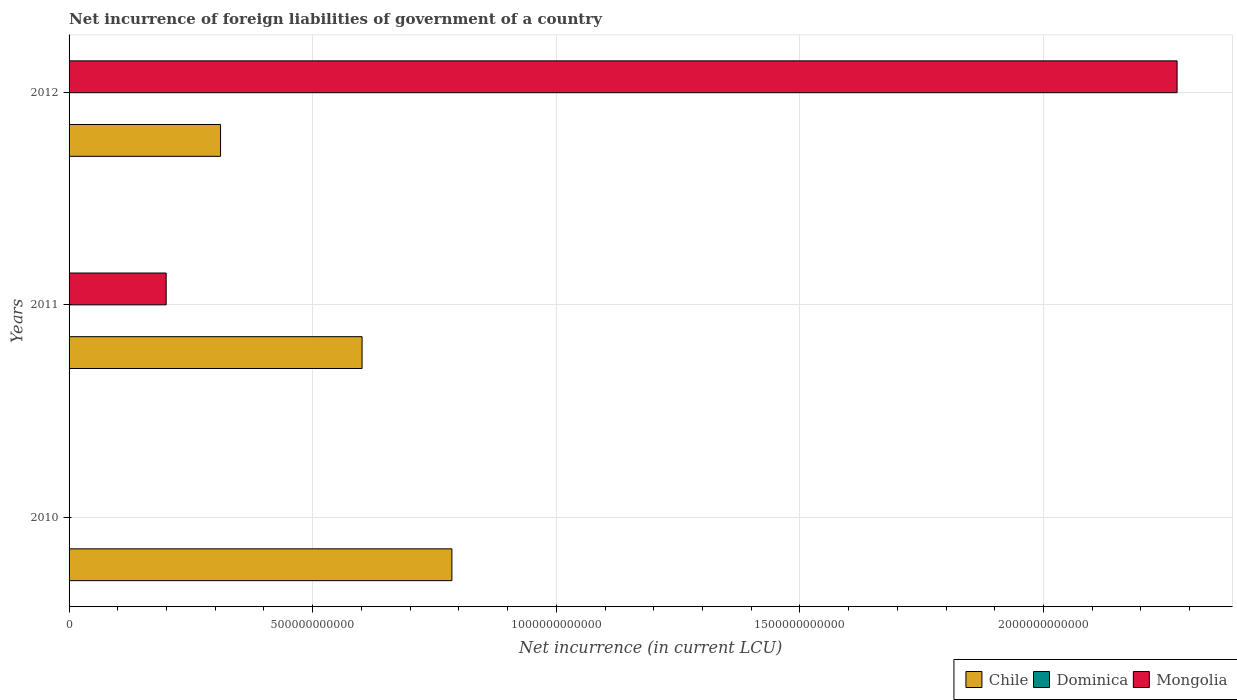How many different coloured bars are there?
Offer a terse response. 3. How many groups of bars are there?
Your response must be concise. 3. Are the number of bars on each tick of the Y-axis equal?
Your answer should be very brief. No. How many bars are there on the 2nd tick from the top?
Give a very brief answer. 3. How many bars are there on the 1st tick from the bottom?
Your response must be concise. 2. In how many cases, is the number of bars for a given year not equal to the number of legend labels?
Provide a succinct answer. 1. What is the net incurrence of foreign liabilities in Dominica in 2012?
Your answer should be very brief. 7.28e+07. Across all years, what is the maximum net incurrence of foreign liabilities in Mongolia?
Provide a succinct answer. 2.27e+12. Across all years, what is the minimum net incurrence of foreign liabilities in Dominica?
Your response must be concise. 2.72e+07. In which year was the net incurrence of foreign liabilities in Dominica maximum?
Your response must be concise. 2012. What is the total net incurrence of foreign liabilities in Dominica in the graph?
Your answer should be very brief. 1.48e+08. What is the difference between the net incurrence of foreign liabilities in Chile in 2010 and that in 2011?
Your response must be concise. 1.84e+11. What is the difference between the net incurrence of foreign liabilities in Mongolia in 2011 and the net incurrence of foreign liabilities in Chile in 2012?
Provide a short and direct response. -1.12e+11. What is the average net incurrence of foreign liabilities in Mongolia per year?
Ensure brevity in your answer.  8.24e+11. In the year 2011, what is the difference between the net incurrence of foreign liabilities in Dominica and net incurrence of foreign liabilities in Chile?
Your answer should be very brief. -6.01e+11. In how many years, is the net incurrence of foreign liabilities in Chile greater than 1500000000000 LCU?
Offer a very short reply. 0. What is the ratio of the net incurrence of foreign liabilities in Dominica in 2010 to that in 2012?
Your response must be concise. 0.66. Is the difference between the net incurrence of foreign liabilities in Dominica in 2010 and 2012 greater than the difference between the net incurrence of foreign liabilities in Chile in 2010 and 2012?
Provide a succinct answer. No. What is the difference between the highest and the second highest net incurrence of foreign liabilities in Dominica?
Your answer should be very brief. 2.48e+07. What is the difference between the highest and the lowest net incurrence of foreign liabilities in Chile?
Provide a short and direct response. 4.75e+11. In how many years, is the net incurrence of foreign liabilities in Chile greater than the average net incurrence of foreign liabilities in Chile taken over all years?
Offer a terse response. 2. Is it the case that in every year, the sum of the net incurrence of foreign liabilities in Dominica and net incurrence of foreign liabilities in Chile is greater than the net incurrence of foreign liabilities in Mongolia?
Provide a succinct answer. No. Are all the bars in the graph horizontal?
Offer a terse response. Yes. What is the difference between two consecutive major ticks on the X-axis?
Provide a short and direct response. 5.00e+11. Are the values on the major ticks of X-axis written in scientific E-notation?
Your answer should be very brief. No. Does the graph contain any zero values?
Offer a terse response. Yes. How many legend labels are there?
Offer a very short reply. 3. How are the legend labels stacked?
Your answer should be compact. Horizontal. What is the title of the graph?
Make the answer very short. Net incurrence of foreign liabilities of government of a country. Does "Guam" appear as one of the legend labels in the graph?
Your answer should be very brief. No. What is the label or title of the X-axis?
Offer a very short reply. Net incurrence (in current LCU). What is the Net incurrence (in current LCU) in Chile in 2010?
Offer a terse response. 7.86e+11. What is the Net incurrence (in current LCU) in Dominica in 2010?
Offer a very short reply. 4.80e+07. What is the Net incurrence (in current LCU) in Chile in 2011?
Make the answer very short. 6.01e+11. What is the Net incurrence (in current LCU) in Dominica in 2011?
Ensure brevity in your answer.  2.72e+07. What is the Net incurrence (in current LCU) of Mongolia in 2011?
Offer a very short reply. 1.99e+11. What is the Net incurrence (in current LCU) of Chile in 2012?
Give a very brief answer. 3.11e+11. What is the Net incurrence (in current LCU) of Dominica in 2012?
Make the answer very short. 7.28e+07. What is the Net incurrence (in current LCU) in Mongolia in 2012?
Your answer should be very brief. 2.27e+12. Across all years, what is the maximum Net incurrence (in current LCU) of Chile?
Offer a terse response. 7.86e+11. Across all years, what is the maximum Net incurrence (in current LCU) of Dominica?
Make the answer very short. 7.28e+07. Across all years, what is the maximum Net incurrence (in current LCU) in Mongolia?
Provide a short and direct response. 2.27e+12. Across all years, what is the minimum Net incurrence (in current LCU) in Chile?
Give a very brief answer. 3.11e+11. Across all years, what is the minimum Net incurrence (in current LCU) of Dominica?
Offer a very short reply. 2.72e+07. Across all years, what is the minimum Net incurrence (in current LCU) in Mongolia?
Provide a succinct answer. 0. What is the total Net incurrence (in current LCU) in Chile in the graph?
Offer a terse response. 1.70e+12. What is the total Net incurrence (in current LCU) of Dominica in the graph?
Your response must be concise. 1.48e+08. What is the total Net incurrence (in current LCU) of Mongolia in the graph?
Ensure brevity in your answer.  2.47e+12. What is the difference between the Net incurrence (in current LCU) in Chile in 2010 and that in 2011?
Ensure brevity in your answer.  1.84e+11. What is the difference between the Net incurrence (in current LCU) in Dominica in 2010 and that in 2011?
Give a very brief answer. 2.08e+07. What is the difference between the Net incurrence (in current LCU) in Chile in 2010 and that in 2012?
Provide a succinct answer. 4.75e+11. What is the difference between the Net incurrence (in current LCU) in Dominica in 2010 and that in 2012?
Your answer should be compact. -2.48e+07. What is the difference between the Net incurrence (in current LCU) of Chile in 2011 and that in 2012?
Offer a terse response. 2.90e+11. What is the difference between the Net incurrence (in current LCU) of Dominica in 2011 and that in 2012?
Your answer should be very brief. -4.56e+07. What is the difference between the Net incurrence (in current LCU) of Mongolia in 2011 and that in 2012?
Your response must be concise. -2.07e+12. What is the difference between the Net incurrence (in current LCU) of Chile in 2010 and the Net incurrence (in current LCU) of Dominica in 2011?
Ensure brevity in your answer.  7.86e+11. What is the difference between the Net incurrence (in current LCU) in Chile in 2010 and the Net incurrence (in current LCU) in Mongolia in 2011?
Ensure brevity in your answer.  5.86e+11. What is the difference between the Net incurrence (in current LCU) in Dominica in 2010 and the Net incurrence (in current LCU) in Mongolia in 2011?
Your response must be concise. -1.99e+11. What is the difference between the Net incurrence (in current LCU) of Chile in 2010 and the Net incurrence (in current LCU) of Dominica in 2012?
Offer a terse response. 7.86e+11. What is the difference between the Net incurrence (in current LCU) in Chile in 2010 and the Net incurrence (in current LCU) in Mongolia in 2012?
Offer a very short reply. -1.49e+12. What is the difference between the Net incurrence (in current LCU) in Dominica in 2010 and the Net incurrence (in current LCU) in Mongolia in 2012?
Keep it short and to the point. -2.27e+12. What is the difference between the Net incurrence (in current LCU) in Chile in 2011 and the Net incurrence (in current LCU) in Dominica in 2012?
Provide a succinct answer. 6.01e+11. What is the difference between the Net incurrence (in current LCU) in Chile in 2011 and the Net incurrence (in current LCU) in Mongolia in 2012?
Ensure brevity in your answer.  -1.67e+12. What is the difference between the Net incurrence (in current LCU) in Dominica in 2011 and the Net incurrence (in current LCU) in Mongolia in 2012?
Make the answer very short. -2.27e+12. What is the average Net incurrence (in current LCU) in Chile per year?
Keep it short and to the point. 5.66e+11. What is the average Net incurrence (in current LCU) in Dominica per year?
Offer a very short reply. 4.93e+07. What is the average Net incurrence (in current LCU) of Mongolia per year?
Your response must be concise. 8.24e+11. In the year 2010, what is the difference between the Net incurrence (in current LCU) in Chile and Net incurrence (in current LCU) in Dominica?
Your response must be concise. 7.86e+11. In the year 2011, what is the difference between the Net incurrence (in current LCU) of Chile and Net incurrence (in current LCU) of Dominica?
Make the answer very short. 6.01e+11. In the year 2011, what is the difference between the Net incurrence (in current LCU) of Chile and Net incurrence (in current LCU) of Mongolia?
Offer a very short reply. 4.02e+11. In the year 2011, what is the difference between the Net incurrence (in current LCU) in Dominica and Net incurrence (in current LCU) in Mongolia?
Offer a very short reply. -1.99e+11. In the year 2012, what is the difference between the Net incurrence (in current LCU) of Chile and Net incurrence (in current LCU) of Dominica?
Your response must be concise. 3.11e+11. In the year 2012, what is the difference between the Net incurrence (in current LCU) in Chile and Net incurrence (in current LCU) in Mongolia?
Make the answer very short. -1.96e+12. In the year 2012, what is the difference between the Net incurrence (in current LCU) of Dominica and Net incurrence (in current LCU) of Mongolia?
Your response must be concise. -2.27e+12. What is the ratio of the Net incurrence (in current LCU) of Chile in 2010 to that in 2011?
Keep it short and to the point. 1.31. What is the ratio of the Net incurrence (in current LCU) of Dominica in 2010 to that in 2011?
Make the answer very short. 1.76. What is the ratio of the Net incurrence (in current LCU) of Chile in 2010 to that in 2012?
Your answer should be compact. 2.53. What is the ratio of the Net incurrence (in current LCU) in Dominica in 2010 to that in 2012?
Offer a very short reply. 0.66. What is the ratio of the Net incurrence (in current LCU) of Chile in 2011 to that in 2012?
Make the answer very short. 1.93. What is the ratio of the Net incurrence (in current LCU) in Dominica in 2011 to that in 2012?
Your answer should be compact. 0.37. What is the ratio of the Net incurrence (in current LCU) of Mongolia in 2011 to that in 2012?
Keep it short and to the point. 0.09. What is the difference between the highest and the second highest Net incurrence (in current LCU) of Chile?
Offer a very short reply. 1.84e+11. What is the difference between the highest and the second highest Net incurrence (in current LCU) in Dominica?
Your answer should be very brief. 2.48e+07. What is the difference between the highest and the lowest Net incurrence (in current LCU) in Chile?
Offer a terse response. 4.75e+11. What is the difference between the highest and the lowest Net incurrence (in current LCU) in Dominica?
Give a very brief answer. 4.56e+07. What is the difference between the highest and the lowest Net incurrence (in current LCU) in Mongolia?
Offer a very short reply. 2.27e+12. 